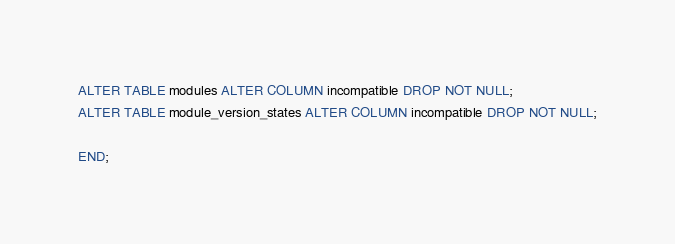<code> <loc_0><loc_0><loc_500><loc_500><_SQL_>
ALTER TABLE modules ALTER COLUMN incompatible DROP NOT NULL;
ALTER TABLE module_version_states ALTER COLUMN incompatible DROP NOT NULL;

END;
</code> 